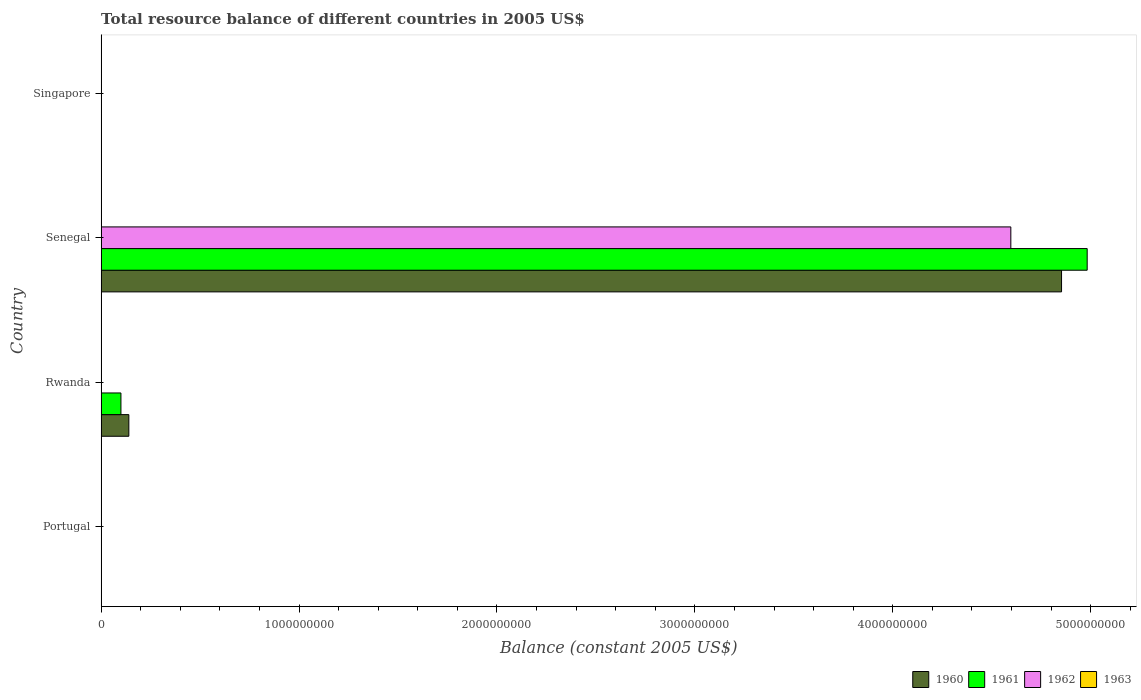How many different coloured bars are there?
Make the answer very short. 3. Are the number of bars on each tick of the Y-axis equal?
Ensure brevity in your answer.  No. How many bars are there on the 2nd tick from the bottom?
Keep it short and to the point. 2. What is the label of the 2nd group of bars from the top?
Ensure brevity in your answer.  Senegal. In how many cases, is the number of bars for a given country not equal to the number of legend labels?
Offer a very short reply. 4. What is the total resource balance in 1963 in Portugal?
Provide a short and direct response. 0. Across all countries, what is the maximum total resource balance in 1961?
Your answer should be compact. 4.98e+09. In which country was the total resource balance in 1960 maximum?
Give a very brief answer. Senegal. What is the total total resource balance in 1961 in the graph?
Make the answer very short. 5.08e+09. What is the difference between the total resource balance in 1962 and total resource balance in 1960 in Senegal?
Make the answer very short. -2.56e+08. In how many countries, is the total resource balance in 1961 greater than 3600000000 US$?
Give a very brief answer. 1. What is the difference between the highest and the lowest total resource balance in 1961?
Provide a succinct answer. 4.98e+09. In how many countries, is the total resource balance in 1960 greater than the average total resource balance in 1960 taken over all countries?
Your answer should be very brief. 1. Are all the bars in the graph horizontal?
Offer a terse response. Yes. Are the values on the major ticks of X-axis written in scientific E-notation?
Offer a very short reply. No. Does the graph contain any zero values?
Give a very brief answer. Yes. Does the graph contain grids?
Offer a very short reply. No. Where does the legend appear in the graph?
Make the answer very short. Bottom right. What is the title of the graph?
Your response must be concise. Total resource balance of different countries in 2005 US$. Does "1974" appear as one of the legend labels in the graph?
Your response must be concise. No. What is the label or title of the X-axis?
Ensure brevity in your answer.  Balance (constant 2005 US$). What is the Balance (constant 2005 US$) of 1960 in Portugal?
Provide a succinct answer. 0. What is the Balance (constant 2005 US$) of 1963 in Portugal?
Provide a short and direct response. 0. What is the Balance (constant 2005 US$) of 1960 in Rwanda?
Make the answer very short. 1.40e+08. What is the Balance (constant 2005 US$) of 1961 in Rwanda?
Provide a short and direct response. 1.00e+08. What is the Balance (constant 2005 US$) of 1963 in Rwanda?
Give a very brief answer. 0. What is the Balance (constant 2005 US$) in 1960 in Senegal?
Offer a terse response. 4.85e+09. What is the Balance (constant 2005 US$) of 1961 in Senegal?
Provide a succinct answer. 4.98e+09. What is the Balance (constant 2005 US$) of 1962 in Senegal?
Your response must be concise. 4.60e+09. What is the Balance (constant 2005 US$) in 1963 in Senegal?
Make the answer very short. 0. What is the Balance (constant 2005 US$) of 1961 in Singapore?
Provide a short and direct response. 0. What is the Balance (constant 2005 US$) in 1963 in Singapore?
Your answer should be very brief. 0. Across all countries, what is the maximum Balance (constant 2005 US$) in 1960?
Your response must be concise. 4.85e+09. Across all countries, what is the maximum Balance (constant 2005 US$) of 1961?
Ensure brevity in your answer.  4.98e+09. Across all countries, what is the maximum Balance (constant 2005 US$) in 1962?
Your answer should be very brief. 4.60e+09. What is the total Balance (constant 2005 US$) of 1960 in the graph?
Your answer should be compact. 4.99e+09. What is the total Balance (constant 2005 US$) in 1961 in the graph?
Your answer should be compact. 5.08e+09. What is the total Balance (constant 2005 US$) in 1962 in the graph?
Provide a short and direct response. 4.60e+09. What is the difference between the Balance (constant 2005 US$) of 1960 in Rwanda and that in Senegal?
Ensure brevity in your answer.  -4.71e+09. What is the difference between the Balance (constant 2005 US$) of 1961 in Rwanda and that in Senegal?
Provide a succinct answer. -4.88e+09. What is the difference between the Balance (constant 2005 US$) in 1960 in Rwanda and the Balance (constant 2005 US$) in 1961 in Senegal?
Your response must be concise. -4.84e+09. What is the difference between the Balance (constant 2005 US$) of 1960 in Rwanda and the Balance (constant 2005 US$) of 1962 in Senegal?
Provide a short and direct response. -4.46e+09. What is the difference between the Balance (constant 2005 US$) in 1961 in Rwanda and the Balance (constant 2005 US$) in 1962 in Senegal?
Keep it short and to the point. -4.50e+09. What is the average Balance (constant 2005 US$) in 1960 per country?
Ensure brevity in your answer.  1.25e+09. What is the average Balance (constant 2005 US$) in 1961 per country?
Your answer should be compact. 1.27e+09. What is the average Balance (constant 2005 US$) in 1962 per country?
Your answer should be compact. 1.15e+09. What is the difference between the Balance (constant 2005 US$) of 1960 and Balance (constant 2005 US$) of 1961 in Rwanda?
Your response must be concise. 4.00e+07. What is the difference between the Balance (constant 2005 US$) of 1960 and Balance (constant 2005 US$) of 1961 in Senegal?
Your answer should be compact. -1.30e+08. What is the difference between the Balance (constant 2005 US$) in 1960 and Balance (constant 2005 US$) in 1962 in Senegal?
Ensure brevity in your answer.  2.56e+08. What is the difference between the Balance (constant 2005 US$) of 1961 and Balance (constant 2005 US$) of 1962 in Senegal?
Offer a terse response. 3.86e+08. What is the ratio of the Balance (constant 2005 US$) in 1960 in Rwanda to that in Senegal?
Your response must be concise. 0.03. What is the ratio of the Balance (constant 2005 US$) in 1961 in Rwanda to that in Senegal?
Offer a terse response. 0.02. What is the difference between the highest and the lowest Balance (constant 2005 US$) of 1960?
Provide a succinct answer. 4.85e+09. What is the difference between the highest and the lowest Balance (constant 2005 US$) of 1961?
Offer a very short reply. 4.98e+09. What is the difference between the highest and the lowest Balance (constant 2005 US$) in 1962?
Your response must be concise. 4.60e+09. 